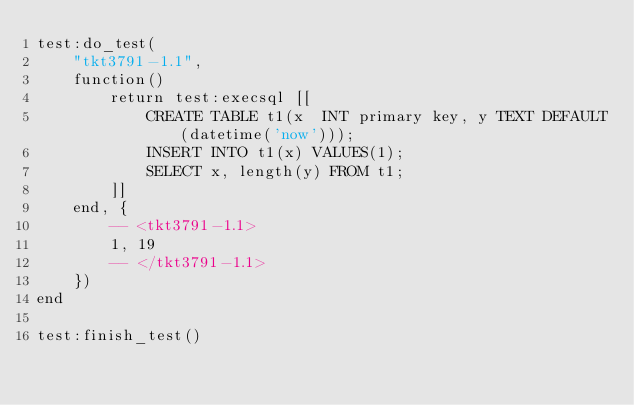<code> <loc_0><loc_0><loc_500><loc_500><_Lua_>test:do_test(
    "tkt3791-1.1",
    function()
        return test:execsql [[
            CREATE TABLE t1(x  INT primary key, y TEXT DEFAULT(datetime('now')));
            INSERT INTO t1(x) VALUES(1);
            SELECT x, length(y) FROM t1;
        ]]
    end, {
        -- <tkt3791-1.1>
        1, 19
        -- </tkt3791-1.1>
    })
end

test:finish_test()

</code> 